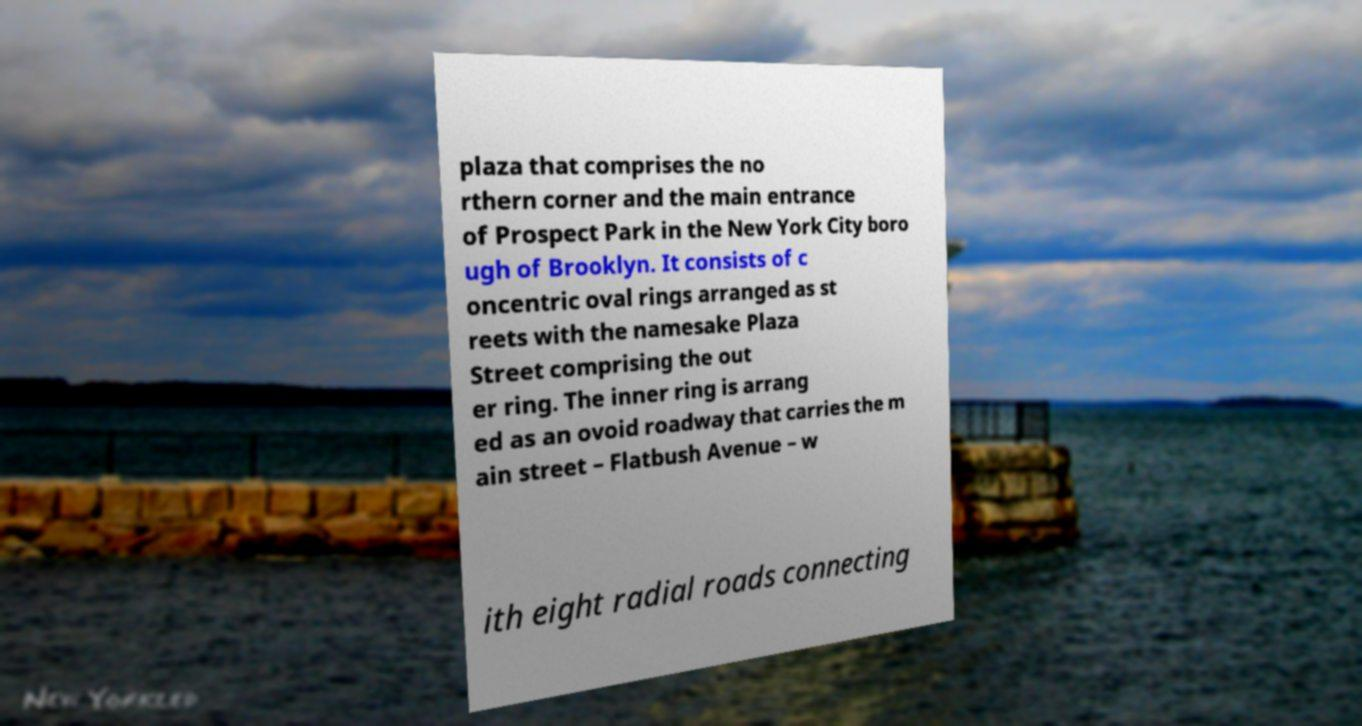Can you read and provide the text displayed in the image?This photo seems to have some interesting text. Can you extract and type it out for me? plaza that comprises the no rthern corner and the main entrance of Prospect Park in the New York City boro ugh of Brooklyn. It consists of c oncentric oval rings arranged as st reets with the namesake Plaza Street comprising the out er ring. The inner ring is arrang ed as an ovoid roadway that carries the m ain street – Flatbush Avenue – w ith eight radial roads connecting 